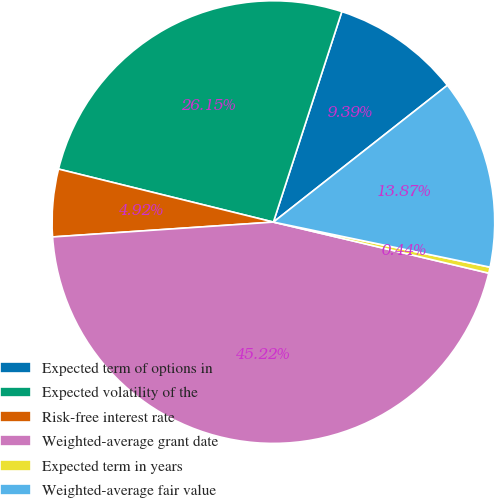Convert chart to OTSL. <chart><loc_0><loc_0><loc_500><loc_500><pie_chart><fcel>Expected term of options in<fcel>Expected volatility of the<fcel>Risk-free interest rate<fcel>Weighted-average grant date<fcel>Expected term in years<fcel>Weighted-average fair value<nl><fcel>9.39%<fcel>26.15%<fcel>4.92%<fcel>45.22%<fcel>0.44%<fcel>13.87%<nl></chart> 